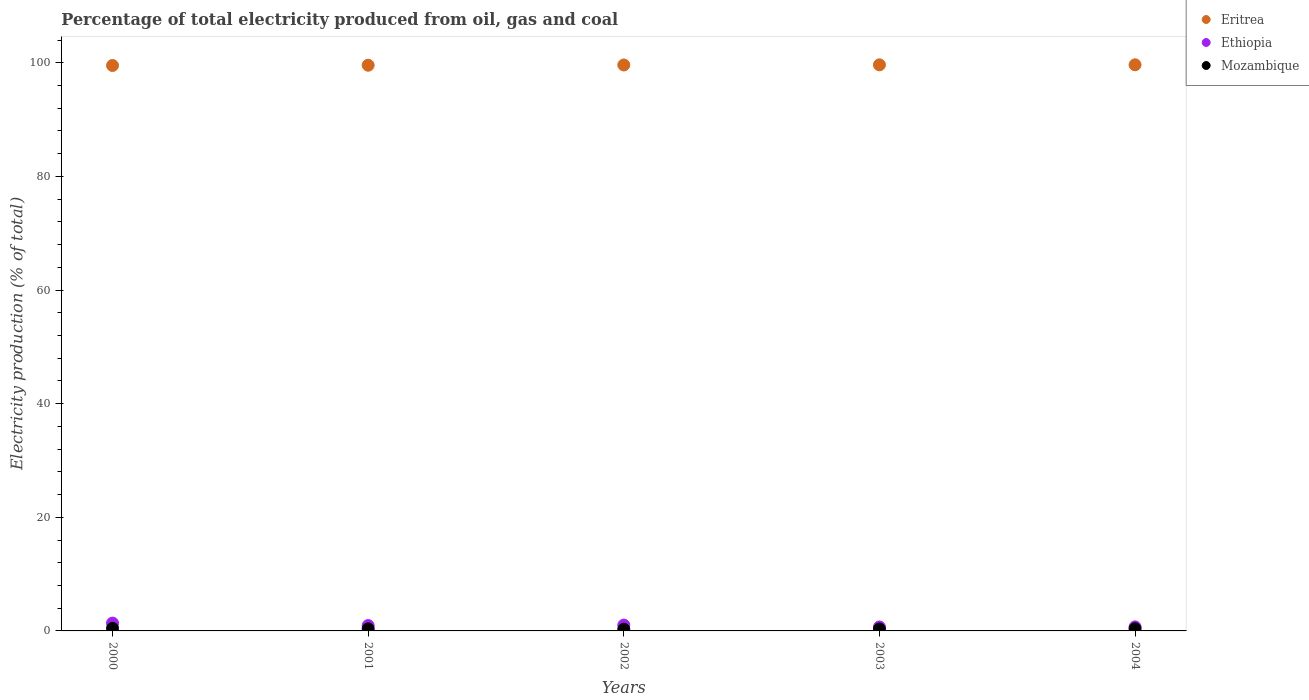Is the number of dotlines equal to the number of legend labels?
Keep it short and to the point. Yes. What is the electricity production in in Eritrea in 2002?
Your response must be concise. 99.61. Across all years, what is the maximum electricity production in in Mozambique?
Offer a terse response. 0.45. Across all years, what is the minimum electricity production in in Ethiopia?
Keep it short and to the point. 0.7. What is the total electricity production in in Eritrea in the graph?
Your response must be concise. 497.99. What is the difference between the electricity production in in Ethiopia in 2002 and that in 2003?
Keep it short and to the point. 0.33. What is the difference between the electricity production in in Ethiopia in 2004 and the electricity production in in Mozambique in 2002?
Keep it short and to the point. 0.41. What is the average electricity production in in Ethiopia per year?
Your answer should be very brief. 0.95. In the year 2003, what is the difference between the electricity production in in Ethiopia and electricity production in in Mozambique?
Your response must be concise. 0.36. What is the ratio of the electricity production in in Eritrea in 2001 to that in 2003?
Your answer should be compact. 1. Is the electricity production in in Ethiopia in 2002 less than that in 2003?
Offer a terse response. No. What is the difference between the highest and the second highest electricity production in in Eritrea?
Your response must be concise. 0.01. What is the difference between the highest and the lowest electricity production in in Eritrea?
Provide a succinct answer. 0.12. In how many years, is the electricity production in in Eritrea greater than the average electricity production in in Eritrea taken over all years?
Offer a terse response. 3. Does the electricity production in in Ethiopia monotonically increase over the years?
Provide a succinct answer. No. How many dotlines are there?
Your response must be concise. 3. How many years are there in the graph?
Provide a short and direct response. 5. Does the graph contain grids?
Your answer should be compact. No. How many legend labels are there?
Keep it short and to the point. 3. How are the legend labels stacked?
Keep it short and to the point. Vertical. What is the title of the graph?
Offer a very short reply. Percentage of total electricity produced from oil, gas and coal. Does "Dominican Republic" appear as one of the legend labels in the graph?
Keep it short and to the point. No. What is the label or title of the Y-axis?
Offer a terse response. Electricity production (% of total). What is the Electricity production (% of total) of Eritrea in 2000?
Your answer should be compact. 99.52. What is the Electricity production (% of total) in Ethiopia in 2000?
Provide a succinct answer. 1.37. What is the Electricity production (% of total) in Mozambique in 2000?
Offer a terse response. 0.45. What is the Electricity production (% of total) of Eritrea in 2001?
Your answer should be very brief. 99.57. What is the Electricity production (% of total) of Ethiopia in 2001?
Ensure brevity in your answer.  0.94. What is the Electricity production (% of total) in Mozambique in 2001?
Keep it short and to the point. 0.37. What is the Electricity production (% of total) of Eritrea in 2002?
Make the answer very short. 99.61. What is the Electricity production (% of total) of Ethiopia in 2002?
Your answer should be compact. 1.03. What is the Electricity production (% of total) of Mozambique in 2002?
Your response must be concise. 0.3. What is the Electricity production (% of total) of Eritrea in 2003?
Provide a succinct answer. 99.64. What is the Electricity production (% of total) of Ethiopia in 2003?
Make the answer very short. 0.7. What is the Electricity production (% of total) of Mozambique in 2003?
Provide a short and direct response. 0.34. What is the Electricity production (% of total) in Eritrea in 2004?
Your answer should be compact. 99.65. What is the Electricity production (% of total) of Ethiopia in 2004?
Make the answer very short. 0.71. What is the Electricity production (% of total) in Mozambique in 2004?
Your response must be concise. 0.39. Across all years, what is the maximum Electricity production (% of total) in Eritrea?
Ensure brevity in your answer.  99.65. Across all years, what is the maximum Electricity production (% of total) of Ethiopia?
Give a very brief answer. 1.37. Across all years, what is the maximum Electricity production (% of total) of Mozambique?
Keep it short and to the point. 0.45. Across all years, what is the minimum Electricity production (% of total) of Eritrea?
Offer a very short reply. 99.52. Across all years, what is the minimum Electricity production (% of total) in Ethiopia?
Keep it short and to the point. 0.7. Across all years, what is the minimum Electricity production (% of total) of Mozambique?
Give a very brief answer. 0.3. What is the total Electricity production (% of total) in Eritrea in the graph?
Your response must be concise. 497.99. What is the total Electricity production (% of total) of Ethiopia in the graph?
Provide a short and direct response. 4.75. What is the total Electricity production (% of total) of Mozambique in the graph?
Provide a short and direct response. 1.85. What is the difference between the Electricity production (% of total) in Eritrea in 2000 and that in 2001?
Provide a succinct answer. -0.05. What is the difference between the Electricity production (% of total) in Ethiopia in 2000 and that in 2001?
Provide a succinct answer. 0.43. What is the difference between the Electricity production (% of total) in Mozambique in 2000 and that in 2001?
Your answer should be compact. 0.08. What is the difference between the Electricity production (% of total) in Eritrea in 2000 and that in 2002?
Keep it short and to the point. -0.09. What is the difference between the Electricity production (% of total) in Ethiopia in 2000 and that in 2002?
Provide a succinct answer. 0.35. What is the difference between the Electricity production (% of total) of Mozambique in 2000 and that in 2002?
Ensure brevity in your answer.  0.15. What is the difference between the Electricity production (% of total) in Eritrea in 2000 and that in 2003?
Give a very brief answer. -0.12. What is the difference between the Electricity production (% of total) of Ethiopia in 2000 and that in 2003?
Make the answer very short. 0.68. What is the difference between the Electricity production (% of total) of Mozambique in 2000 and that in 2003?
Make the answer very short. 0.11. What is the difference between the Electricity production (% of total) of Eritrea in 2000 and that in 2004?
Provide a short and direct response. -0.12. What is the difference between the Electricity production (% of total) of Ethiopia in 2000 and that in 2004?
Your answer should be very brief. 0.67. What is the difference between the Electricity production (% of total) in Mozambique in 2000 and that in 2004?
Your answer should be compact. 0.06. What is the difference between the Electricity production (% of total) of Eritrea in 2001 and that in 2002?
Your response must be concise. -0.04. What is the difference between the Electricity production (% of total) in Ethiopia in 2001 and that in 2002?
Your answer should be very brief. -0.08. What is the difference between the Electricity production (% of total) in Mozambique in 2001 and that in 2002?
Your answer should be compact. 0.07. What is the difference between the Electricity production (% of total) in Eritrea in 2001 and that in 2003?
Provide a succinct answer. -0.07. What is the difference between the Electricity production (% of total) in Ethiopia in 2001 and that in 2003?
Give a very brief answer. 0.25. What is the difference between the Electricity production (% of total) in Mozambique in 2001 and that in 2003?
Your response must be concise. 0.03. What is the difference between the Electricity production (% of total) of Eritrea in 2001 and that in 2004?
Your response must be concise. -0.08. What is the difference between the Electricity production (% of total) of Ethiopia in 2001 and that in 2004?
Make the answer very short. 0.24. What is the difference between the Electricity production (% of total) of Mozambique in 2001 and that in 2004?
Keep it short and to the point. -0.02. What is the difference between the Electricity production (% of total) in Eritrea in 2002 and that in 2003?
Make the answer very short. -0.03. What is the difference between the Electricity production (% of total) in Ethiopia in 2002 and that in 2003?
Ensure brevity in your answer.  0.33. What is the difference between the Electricity production (% of total) of Mozambique in 2002 and that in 2003?
Your answer should be very brief. -0.04. What is the difference between the Electricity production (% of total) in Eritrea in 2002 and that in 2004?
Provide a succinct answer. -0.03. What is the difference between the Electricity production (% of total) in Ethiopia in 2002 and that in 2004?
Your answer should be compact. 0.32. What is the difference between the Electricity production (% of total) in Mozambique in 2002 and that in 2004?
Make the answer very short. -0.09. What is the difference between the Electricity production (% of total) in Eritrea in 2003 and that in 2004?
Provide a short and direct response. -0.01. What is the difference between the Electricity production (% of total) of Ethiopia in 2003 and that in 2004?
Offer a terse response. -0.01. What is the difference between the Electricity production (% of total) in Mozambique in 2003 and that in 2004?
Give a very brief answer. -0.05. What is the difference between the Electricity production (% of total) in Eritrea in 2000 and the Electricity production (% of total) in Ethiopia in 2001?
Make the answer very short. 98.58. What is the difference between the Electricity production (% of total) of Eritrea in 2000 and the Electricity production (% of total) of Mozambique in 2001?
Offer a very short reply. 99.15. What is the difference between the Electricity production (% of total) of Ethiopia in 2000 and the Electricity production (% of total) of Mozambique in 2001?
Give a very brief answer. 1. What is the difference between the Electricity production (% of total) in Eritrea in 2000 and the Electricity production (% of total) in Ethiopia in 2002?
Your answer should be very brief. 98.5. What is the difference between the Electricity production (% of total) of Eritrea in 2000 and the Electricity production (% of total) of Mozambique in 2002?
Give a very brief answer. 99.22. What is the difference between the Electricity production (% of total) in Ethiopia in 2000 and the Electricity production (% of total) in Mozambique in 2002?
Give a very brief answer. 1.07. What is the difference between the Electricity production (% of total) in Eritrea in 2000 and the Electricity production (% of total) in Ethiopia in 2003?
Offer a very short reply. 98.83. What is the difference between the Electricity production (% of total) in Eritrea in 2000 and the Electricity production (% of total) in Mozambique in 2003?
Make the answer very short. 99.18. What is the difference between the Electricity production (% of total) in Ethiopia in 2000 and the Electricity production (% of total) in Mozambique in 2003?
Offer a very short reply. 1.03. What is the difference between the Electricity production (% of total) of Eritrea in 2000 and the Electricity production (% of total) of Ethiopia in 2004?
Your answer should be compact. 98.81. What is the difference between the Electricity production (% of total) of Eritrea in 2000 and the Electricity production (% of total) of Mozambique in 2004?
Provide a succinct answer. 99.13. What is the difference between the Electricity production (% of total) in Ethiopia in 2000 and the Electricity production (% of total) in Mozambique in 2004?
Your answer should be very brief. 0.98. What is the difference between the Electricity production (% of total) in Eritrea in 2001 and the Electricity production (% of total) in Ethiopia in 2002?
Provide a short and direct response. 98.54. What is the difference between the Electricity production (% of total) of Eritrea in 2001 and the Electricity production (% of total) of Mozambique in 2002?
Your answer should be very brief. 99.27. What is the difference between the Electricity production (% of total) in Ethiopia in 2001 and the Electricity production (% of total) in Mozambique in 2002?
Provide a short and direct response. 0.65. What is the difference between the Electricity production (% of total) in Eritrea in 2001 and the Electricity production (% of total) in Ethiopia in 2003?
Give a very brief answer. 98.87. What is the difference between the Electricity production (% of total) of Eritrea in 2001 and the Electricity production (% of total) of Mozambique in 2003?
Make the answer very short. 99.23. What is the difference between the Electricity production (% of total) in Ethiopia in 2001 and the Electricity production (% of total) in Mozambique in 2003?
Offer a terse response. 0.61. What is the difference between the Electricity production (% of total) in Eritrea in 2001 and the Electricity production (% of total) in Ethiopia in 2004?
Make the answer very short. 98.86. What is the difference between the Electricity production (% of total) in Eritrea in 2001 and the Electricity production (% of total) in Mozambique in 2004?
Offer a terse response. 99.18. What is the difference between the Electricity production (% of total) of Ethiopia in 2001 and the Electricity production (% of total) of Mozambique in 2004?
Your answer should be compact. 0.55. What is the difference between the Electricity production (% of total) of Eritrea in 2002 and the Electricity production (% of total) of Ethiopia in 2003?
Keep it short and to the point. 98.92. What is the difference between the Electricity production (% of total) of Eritrea in 2002 and the Electricity production (% of total) of Mozambique in 2003?
Keep it short and to the point. 99.27. What is the difference between the Electricity production (% of total) in Ethiopia in 2002 and the Electricity production (% of total) in Mozambique in 2003?
Keep it short and to the point. 0.69. What is the difference between the Electricity production (% of total) of Eritrea in 2002 and the Electricity production (% of total) of Ethiopia in 2004?
Your answer should be very brief. 98.91. What is the difference between the Electricity production (% of total) of Eritrea in 2002 and the Electricity production (% of total) of Mozambique in 2004?
Your answer should be very brief. 99.22. What is the difference between the Electricity production (% of total) in Ethiopia in 2002 and the Electricity production (% of total) in Mozambique in 2004?
Give a very brief answer. 0.63. What is the difference between the Electricity production (% of total) of Eritrea in 2003 and the Electricity production (% of total) of Ethiopia in 2004?
Your response must be concise. 98.93. What is the difference between the Electricity production (% of total) of Eritrea in 2003 and the Electricity production (% of total) of Mozambique in 2004?
Make the answer very short. 99.25. What is the difference between the Electricity production (% of total) of Ethiopia in 2003 and the Electricity production (% of total) of Mozambique in 2004?
Give a very brief answer. 0.3. What is the average Electricity production (% of total) in Eritrea per year?
Ensure brevity in your answer.  99.6. What is the average Electricity production (% of total) in Ethiopia per year?
Ensure brevity in your answer.  0.95. What is the average Electricity production (% of total) of Mozambique per year?
Provide a succinct answer. 0.37. In the year 2000, what is the difference between the Electricity production (% of total) of Eritrea and Electricity production (% of total) of Ethiopia?
Provide a short and direct response. 98.15. In the year 2000, what is the difference between the Electricity production (% of total) in Eritrea and Electricity production (% of total) in Mozambique?
Keep it short and to the point. 99.07. In the year 2000, what is the difference between the Electricity production (% of total) in Ethiopia and Electricity production (% of total) in Mozambique?
Give a very brief answer. 0.92. In the year 2001, what is the difference between the Electricity production (% of total) in Eritrea and Electricity production (% of total) in Ethiopia?
Provide a short and direct response. 98.63. In the year 2001, what is the difference between the Electricity production (% of total) of Eritrea and Electricity production (% of total) of Mozambique?
Provide a short and direct response. 99.2. In the year 2001, what is the difference between the Electricity production (% of total) in Ethiopia and Electricity production (% of total) in Mozambique?
Offer a very short reply. 0.57. In the year 2002, what is the difference between the Electricity production (% of total) of Eritrea and Electricity production (% of total) of Ethiopia?
Keep it short and to the point. 98.59. In the year 2002, what is the difference between the Electricity production (% of total) in Eritrea and Electricity production (% of total) in Mozambique?
Provide a succinct answer. 99.31. In the year 2002, what is the difference between the Electricity production (% of total) in Ethiopia and Electricity production (% of total) in Mozambique?
Offer a terse response. 0.73. In the year 2003, what is the difference between the Electricity production (% of total) in Eritrea and Electricity production (% of total) in Ethiopia?
Make the answer very short. 98.94. In the year 2003, what is the difference between the Electricity production (% of total) in Eritrea and Electricity production (% of total) in Mozambique?
Give a very brief answer. 99.3. In the year 2003, what is the difference between the Electricity production (% of total) in Ethiopia and Electricity production (% of total) in Mozambique?
Keep it short and to the point. 0.36. In the year 2004, what is the difference between the Electricity production (% of total) of Eritrea and Electricity production (% of total) of Ethiopia?
Make the answer very short. 98.94. In the year 2004, what is the difference between the Electricity production (% of total) in Eritrea and Electricity production (% of total) in Mozambique?
Ensure brevity in your answer.  99.25. In the year 2004, what is the difference between the Electricity production (% of total) of Ethiopia and Electricity production (% of total) of Mozambique?
Provide a succinct answer. 0.32. What is the ratio of the Electricity production (% of total) in Eritrea in 2000 to that in 2001?
Offer a terse response. 1. What is the ratio of the Electricity production (% of total) of Ethiopia in 2000 to that in 2001?
Your answer should be compact. 1.45. What is the ratio of the Electricity production (% of total) of Mozambique in 2000 to that in 2001?
Give a very brief answer. 1.23. What is the ratio of the Electricity production (% of total) in Ethiopia in 2000 to that in 2002?
Your response must be concise. 1.34. What is the ratio of the Electricity production (% of total) in Mozambique in 2000 to that in 2002?
Make the answer very short. 1.52. What is the ratio of the Electricity production (% of total) of Ethiopia in 2000 to that in 2003?
Provide a succinct answer. 1.97. What is the ratio of the Electricity production (% of total) in Mozambique in 2000 to that in 2003?
Make the answer very short. 1.34. What is the ratio of the Electricity production (% of total) of Ethiopia in 2000 to that in 2004?
Ensure brevity in your answer.  1.94. What is the ratio of the Electricity production (% of total) of Mozambique in 2000 to that in 2004?
Your answer should be very brief. 1.16. What is the ratio of the Electricity production (% of total) in Ethiopia in 2001 to that in 2002?
Provide a succinct answer. 0.92. What is the ratio of the Electricity production (% of total) of Mozambique in 2001 to that in 2002?
Offer a terse response. 1.24. What is the ratio of the Electricity production (% of total) of Eritrea in 2001 to that in 2003?
Provide a succinct answer. 1. What is the ratio of the Electricity production (% of total) in Ethiopia in 2001 to that in 2003?
Offer a terse response. 1.36. What is the ratio of the Electricity production (% of total) of Mozambique in 2001 to that in 2003?
Keep it short and to the point. 1.09. What is the ratio of the Electricity production (% of total) in Ethiopia in 2001 to that in 2004?
Provide a succinct answer. 1.33. What is the ratio of the Electricity production (% of total) in Mozambique in 2001 to that in 2004?
Give a very brief answer. 0.94. What is the ratio of the Electricity production (% of total) in Eritrea in 2002 to that in 2003?
Keep it short and to the point. 1. What is the ratio of the Electricity production (% of total) of Ethiopia in 2002 to that in 2003?
Offer a very short reply. 1.47. What is the ratio of the Electricity production (% of total) in Mozambique in 2002 to that in 2003?
Your answer should be very brief. 0.88. What is the ratio of the Electricity production (% of total) in Eritrea in 2002 to that in 2004?
Offer a terse response. 1. What is the ratio of the Electricity production (% of total) of Ethiopia in 2002 to that in 2004?
Make the answer very short. 1.45. What is the ratio of the Electricity production (% of total) of Mozambique in 2002 to that in 2004?
Provide a short and direct response. 0.76. What is the ratio of the Electricity production (% of total) in Eritrea in 2003 to that in 2004?
Offer a terse response. 1. What is the ratio of the Electricity production (% of total) in Ethiopia in 2003 to that in 2004?
Ensure brevity in your answer.  0.98. What is the ratio of the Electricity production (% of total) in Mozambique in 2003 to that in 2004?
Offer a terse response. 0.86. What is the difference between the highest and the second highest Electricity production (% of total) of Eritrea?
Ensure brevity in your answer.  0.01. What is the difference between the highest and the second highest Electricity production (% of total) in Ethiopia?
Offer a terse response. 0.35. What is the difference between the highest and the second highest Electricity production (% of total) of Mozambique?
Make the answer very short. 0.06. What is the difference between the highest and the lowest Electricity production (% of total) in Eritrea?
Give a very brief answer. 0.12. What is the difference between the highest and the lowest Electricity production (% of total) in Ethiopia?
Provide a succinct answer. 0.68. What is the difference between the highest and the lowest Electricity production (% of total) of Mozambique?
Keep it short and to the point. 0.15. 